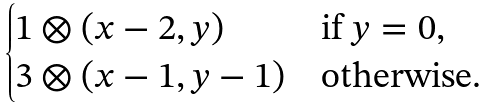<formula> <loc_0><loc_0><loc_500><loc_500>\begin{cases} 1 \otimes ( x - 2 , y ) & \text {if $y=0$} , \\ 3 \otimes ( x - 1 , y - 1 ) & \text {otherwise} . \end{cases}</formula> 